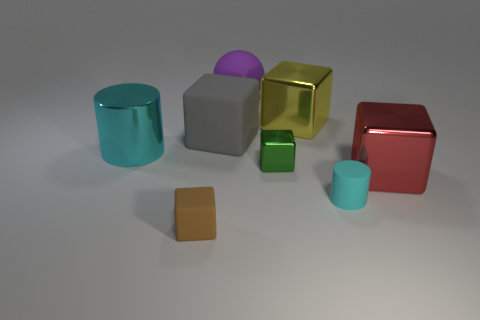There is a metallic object that is the same color as the tiny matte cylinder; what shape is it?
Your answer should be compact. Cylinder. Are there any objects that have the same color as the tiny cylinder?
Your response must be concise. Yes. There is a big shiny thing on the left side of the brown object; is its color the same as the cylinder in front of the large red block?
Your answer should be compact. Yes. What size is the other cylinder that is the same color as the big metallic cylinder?
Offer a very short reply. Small. There is a big metal object that is to the right of the big purple ball and to the left of the cyan matte cylinder; what is its color?
Make the answer very short. Yellow. There is a cylinder left of the brown block; does it have the same color as the small cylinder?
Ensure brevity in your answer.  Yes. How many spheres are either green metal things or tiny brown matte objects?
Keep it short and to the point. 0. What is the shape of the small object that is behind the big red cube?
Keep it short and to the point. Cube. There is a rubber thing on the right side of the large shiny object behind the cyan thing that is left of the tiny green metallic cube; what is its color?
Ensure brevity in your answer.  Cyan. Do the red cube and the small cyan cylinder have the same material?
Offer a very short reply. No. 